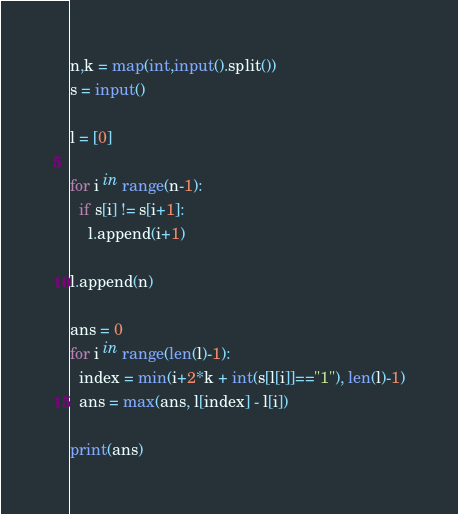<code> <loc_0><loc_0><loc_500><loc_500><_Python_>n,k = map(int,input().split())
s = input()

l = [0]

for i in range(n-1):
  if s[i] != s[i+1]:
    l.append(i+1)

l.append(n)

ans = 0
for i in range(len(l)-1):
  index = min(i+2*k + int(s[l[i]]=="1"), len(l)-1)
  ans = max(ans, l[index] - l[i])

print(ans)</code> 